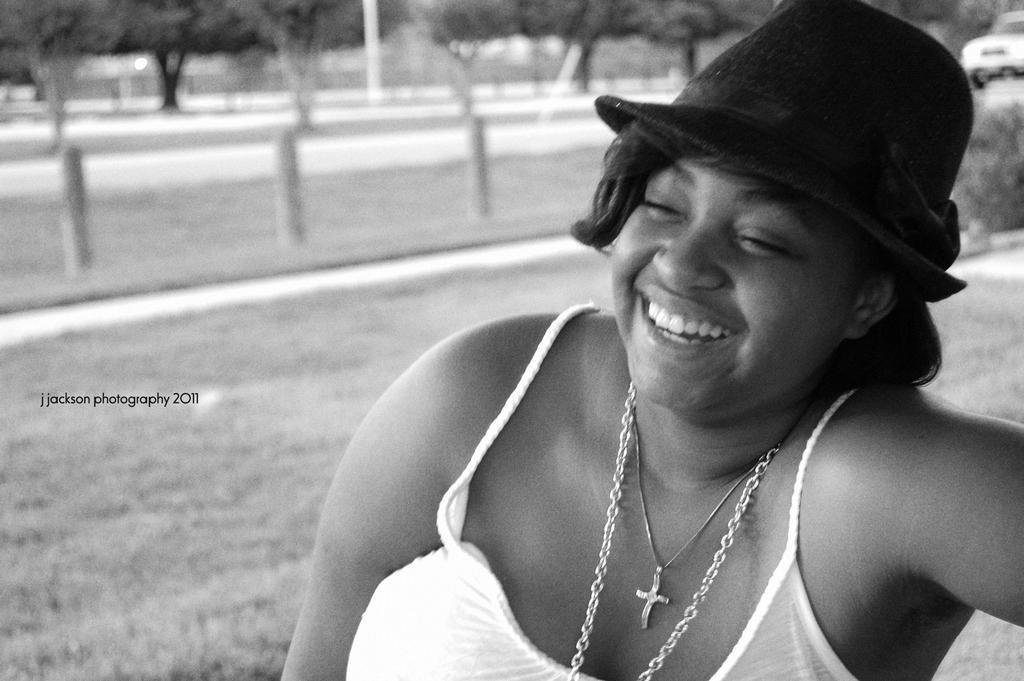In one or two sentences, can you explain what this image depicts? In this image I can see the person and the person is wearing a cap. Background I can see few trees and poles, and the image is in black and white. 